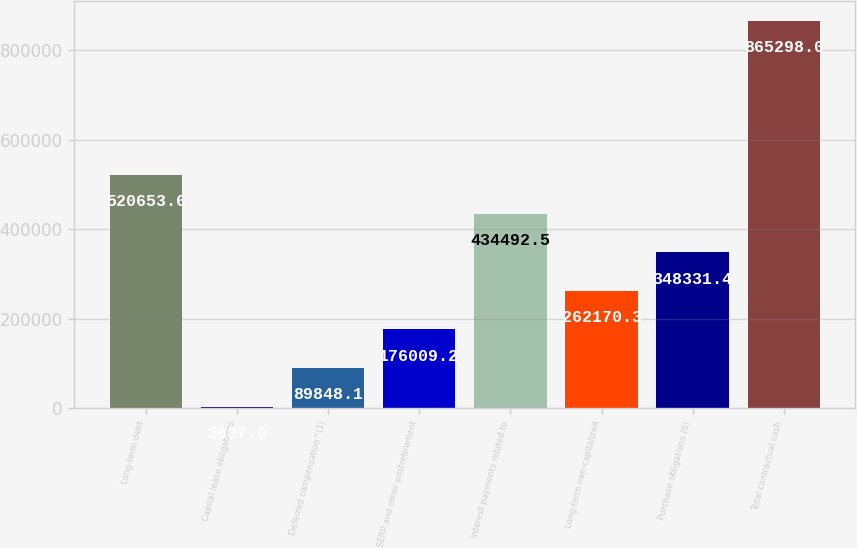<chart> <loc_0><loc_0><loc_500><loc_500><bar_chart><fcel>Long-term debt<fcel>Capital lease obligations<fcel>Deferred compensation^(1)<fcel>SERP and other postretirement<fcel>Interest payments related to<fcel>Long-term non-capitalized<fcel>Purchase obligations (6)<fcel>Total contractual cash<nl><fcel>520654<fcel>3687<fcel>89848.1<fcel>176009<fcel>434492<fcel>262170<fcel>348331<fcel>865298<nl></chart> 